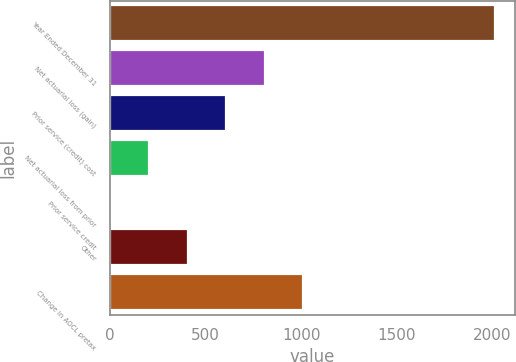<chart> <loc_0><loc_0><loc_500><loc_500><bar_chart><fcel>Year Ended December 31<fcel>Net actuarial loss (gain)<fcel>Prior service (credit) cost<fcel>Net actuarial loss from prior<fcel>Prior service credit<fcel>Other<fcel>Change in AOCL pretax<nl><fcel>2015<fcel>809<fcel>608<fcel>206<fcel>5<fcel>407<fcel>1010<nl></chart> 